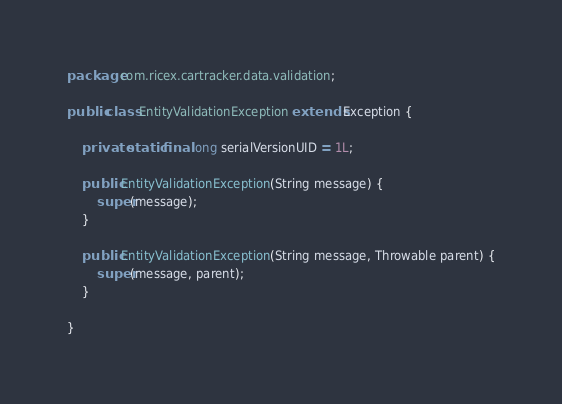Convert code to text. <code><loc_0><loc_0><loc_500><loc_500><_Java_>package com.ricex.cartracker.data.validation;

public class EntityValidationException extends Exception {
	
	private static final long serialVersionUID = 1L;
	
	public EntityValidationException(String message) {
		super(message);
	}
	
	public EntityValidationException(String message, Throwable parent) {
		super(message, parent);
	}

}
</code> 